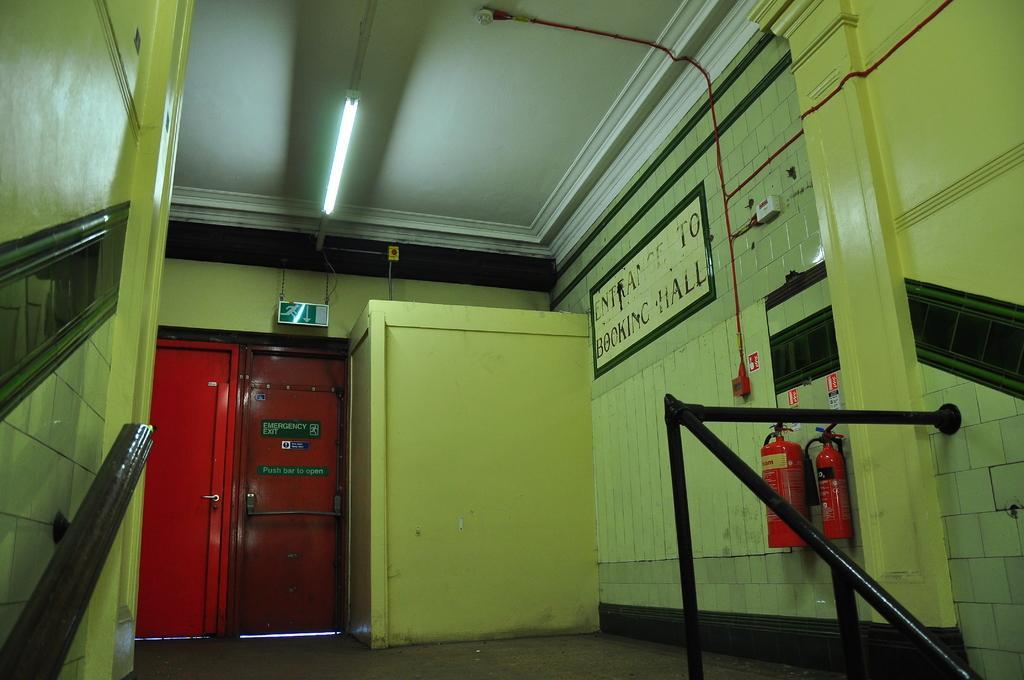Describe this image in one or two sentences. On the left side of the image there is a wall with railing. And on the right side of the image there is a wall with railing and also there are fire extinguishers are on the wall. And also there are red pipes and a poster with something written on it. Beside that there is a small room. In the background there are two red doors with something written on it. Above that there is a sign board hanging with chain. At the top of the image there is a tube light.  